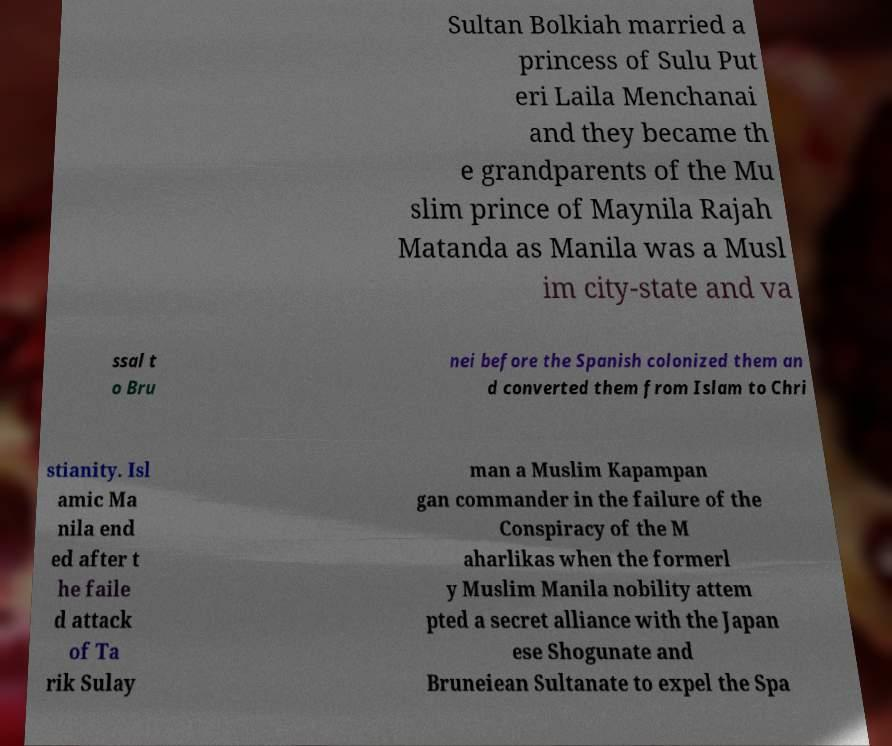Please identify and transcribe the text found in this image. Sultan Bolkiah married a princess of Sulu Put eri Laila Menchanai and they became th e grandparents of the Mu slim prince of Maynila Rajah Matanda as Manila was a Musl im city-state and va ssal t o Bru nei before the Spanish colonized them an d converted them from Islam to Chri stianity. Isl amic Ma nila end ed after t he faile d attack of Ta rik Sulay man a Muslim Kapampan gan commander in the failure of the Conspiracy of the M aharlikas when the formerl y Muslim Manila nobility attem pted a secret alliance with the Japan ese Shogunate and Bruneiean Sultanate to expel the Spa 